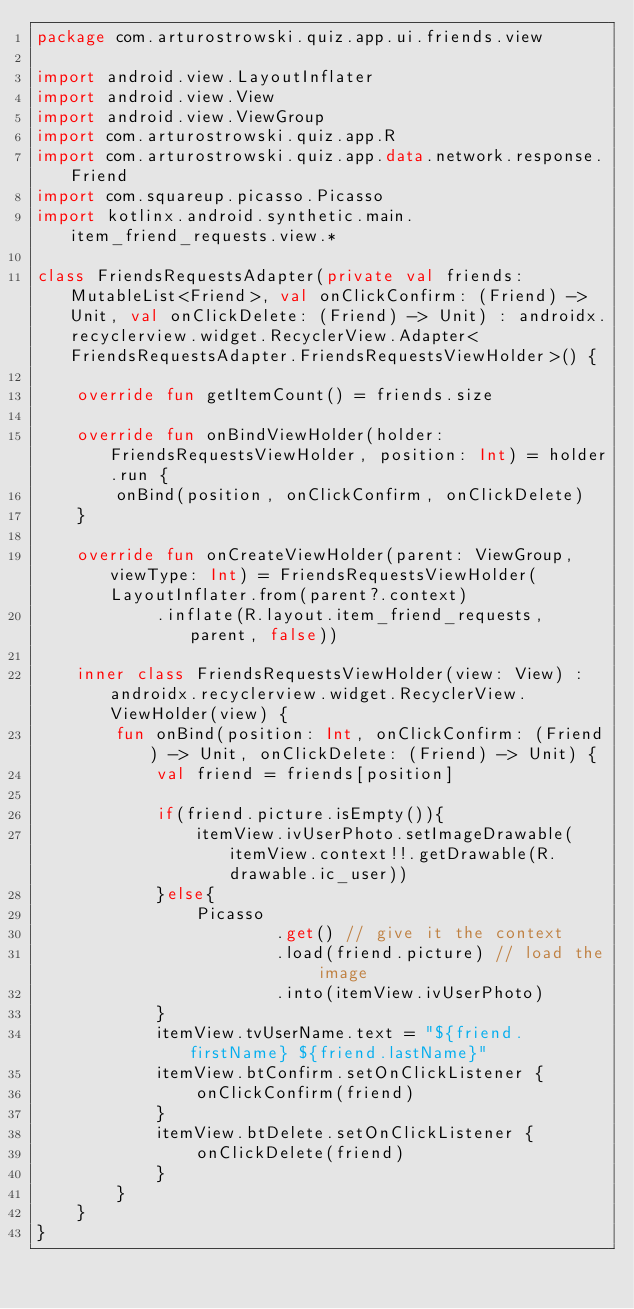<code> <loc_0><loc_0><loc_500><loc_500><_Kotlin_>package com.arturostrowski.quiz.app.ui.friends.view

import android.view.LayoutInflater
import android.view.View
import android.view.ViewGroup
import com.arturostrowski.quiz.app.R
import com.arturostrowski.quiz.app.data.network.response.Friend
import com.squareup.picasso.Picasso
import kotlinx.android.synthetic.main.item_friend_requests.view.*

class FriendsRequestsAdapter(private val friends: MutableList<Friend>, val onClickConfirm: (Friend) -> Unit, val onClickDelete: (Friend) -> Unit) : androidx.recyclerview.widget.RecyclerView.Adapter<FriendsRequestsAdapter.FriendsRequestsViewHolder>() {

    override fun getItemCount() = friends.size

    override fun onBindViewHolder(holder: FriendsRequestsViewHolder, position: Int) = holder.run {
        onBind(position, onClickConfirm, onClickDelete)
    }

    override fun onCreateViewHolder(parent: ViewGroup, viewType: Int) = FriendsRequestsViewHolder(LayoutInflater.from(parent?.context)
            .inflate(R.layout.item_friend_requests, parent, false))

    inner class FriendsRequestsViewHolder(view: View) : androidx.recyclerview.widget.RecyclerView.ViewHolder(view) {
        fun onBind(position: Int, onClickConfirm: (Friend) -> Unit, onClickDelete: (Friend) -> Unit) {
            val friend = friends[position]

            if(friend.picture.isEmpty()){
                itemView.ivUserPhoto.setImageDrawable(itemView.context!!.getDrawable(R.drawable.ic_user))
            }else{
                Picasso
                        .get() // give it the context
                        .load(friend.picture) // load the image
                        .into(itemView.ivUserPhoto)
            }
            itemView.tvUserName.text = "${friend.firstName} ${friend.lastName}"
            itemView.btConfirm.setOnClickListener {
                onClickConfirm(friend)
            }
            itemView.btDelete.setOnClickListener {
                onClickDelete(friend)
            }
        }
    }
}
</code> 